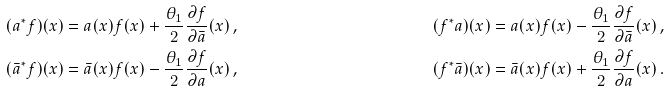Convert formula to latex. <formula><loc_0><loc_0><loc_500><loc_500>( a ^ { * } f ) ( x ) & = a ( x ) f ( x ) + \frac { \theta _ { 1 } } { 2 } \frac { \partial f } { \partial \bar { a } } ( x ) \, , & ( f ^ { * } a ) ( x ) & = a ( x ) f ( x ) - \frac { \theta _ { 1 } } { 2 } \frac { \partial f } { \partial \bar { a } } ( x ) \, , \\ ( \bar { a } ^ { * } f ) ( x ) & = \bar { a } ( x ) f ( x ) - \frac { \theta _ { 1 } } { 2 } \frac { \partial f } { \partial a } ( x ) \, , & ( f ^ { * } \bar { a } ) ( x ) & = \bar { a } ( x ) f ( x ) + \frac { \theta _ { 1 } } { 2 } \frac { \partial f } { \partial a } ( x ) \, .</formula> 